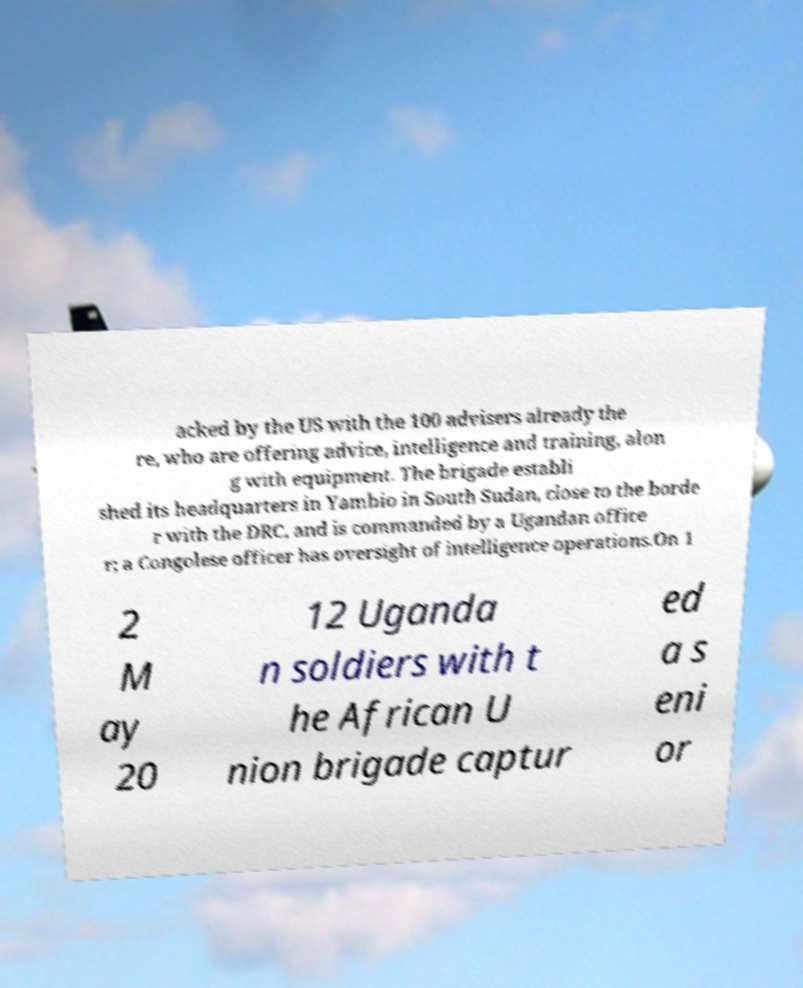I need the written content from this picture converted into text. Can you do that? acked by the US with the 100 advisers already the re, who are offering advice, intelligence and training, alon g with equipment. The brigade establi shed its headquarters in Yambio in South Sudan, close to the borde r with the DRC, and is commanded by a Ugandan office r; a Congolese officer has oversight of intelligence operations.On 1 2 M ay 20 12 Uganda n soldiers with t he African U nion brigade captur ed a s eni or 